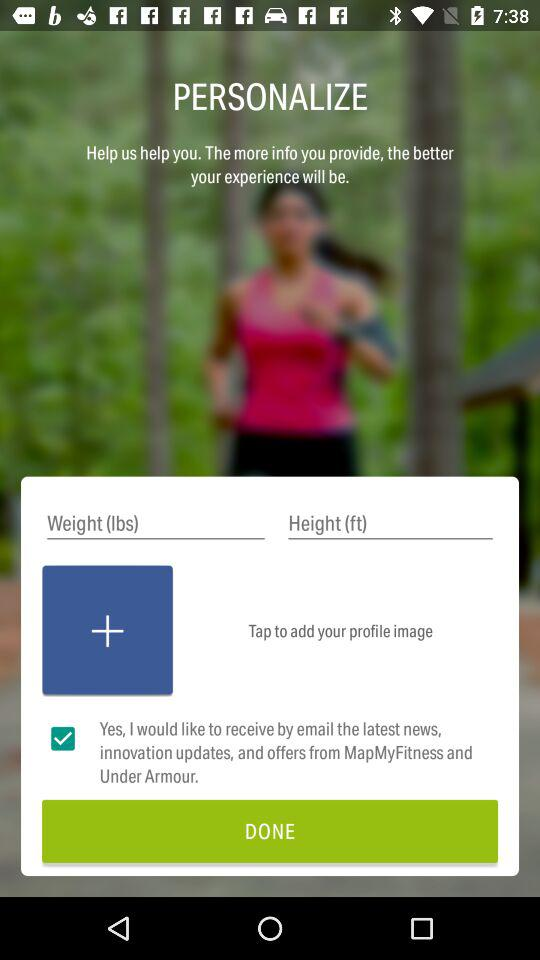What is the name of the application? The name of the application is "MapMyFitness". 